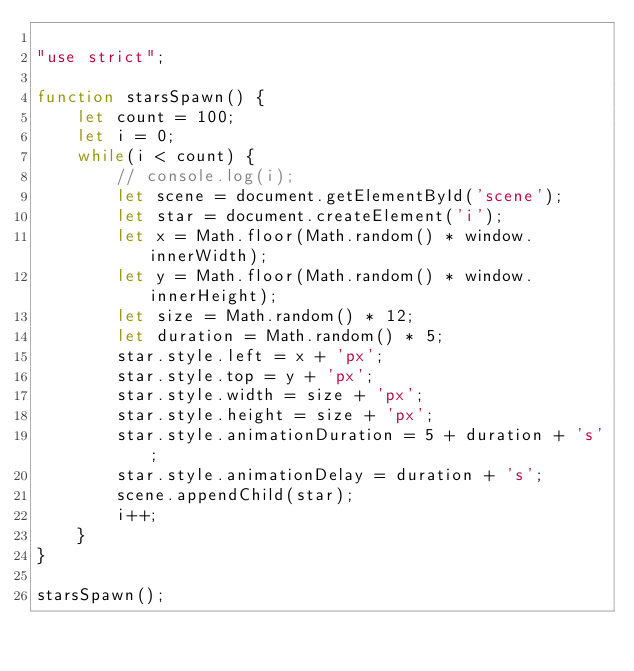Convert code to text. <code><loc_0><loc_0><loc_500><loc_500><_JavaScript_>
"use strict";

function starsSpawn() {
    let count = 100;
    let i = 0;
    while(i < count) {
        // console.log(i);
        let scene = document.getElementById('scene');
        let star = document.createElement('i');
        let x = Math.floor(Math.random() * window.innerWidth);
        let y = Math.floor(Math.random() * window.innerHeight);
        let size = Math.random() * 12;
        let duration = Math.random() * 5;
        star.style.left = x + 'px';
        star.style.top = y + 'px';
        star.style.width = size + 'px';
        star.style.height = size + 'px';
        star.style.animationDuration = 5 + duration + 's';
        star.style.animationDelay = duration + 's';
        scene.appendChild(star);
        i++;
    }
}

starsSpawn();
</code> 